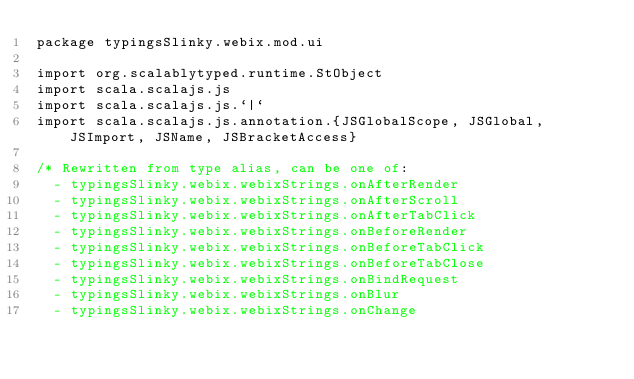<code> <loc_0><loc_0><loc_500><loc_500><_Scala_>package typingsSlinky.webix.mod.ui

import org.scalablytyped.runtime.StObject
import scala.scalajs.js
import scala.scalajs.js.`|`
import scala.scalajs.js.annotation.{JSGlobalScope, JSGlobal, JSImport, JSName, JSBracketAccess}

/* Rewritten from type alias, can be one of: 
  - typingsSlinky.webix.webixStrings.onAfterRender
  - typingsSlinky.webix.webixStrings.onAfterScroll
  - typingsSlinky.webix.webixStrings.onAfterTabClick
  - typingsSlinky.webix.webixStrings.onBeforeRender
  - typingsSlinky.webix.webixStrings.onBeforeTabClick
  - typingsSlinky.webix.webixStrings.onBeforeTabClose
  - typingsSlinky.webix.webixStrings.onBindRequest
  - typingsSlinky.webix.webixStrings.onBlur
  - typingsSlinky.webix.webixStrings.onChange</code> 